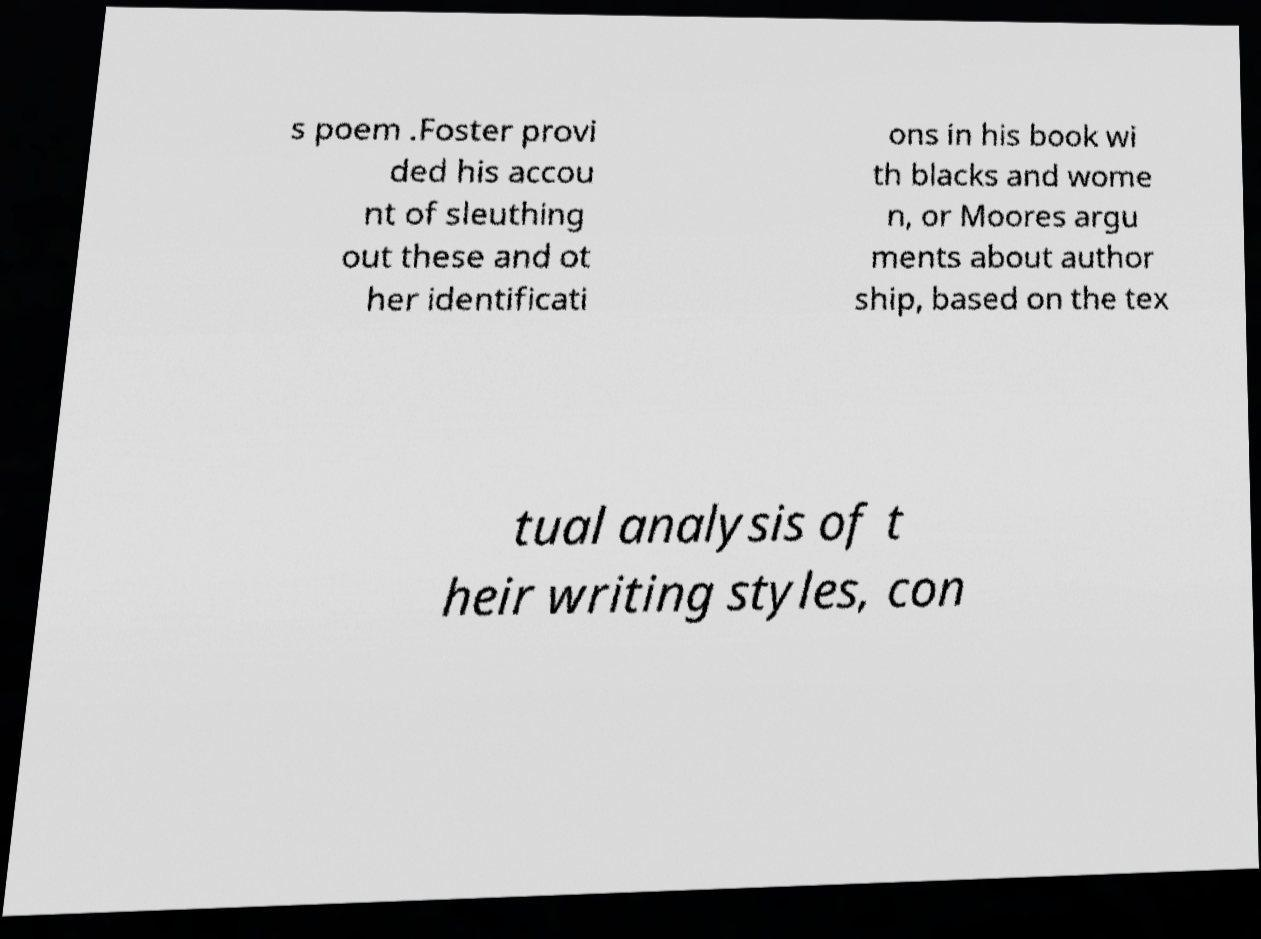Please identify and transcribe the text found in this image. s poem .Foster provi ded his accou nt of sleuthing out these and ot her identificati ons in his book wi th blacks and wome n, or Moores argu ments about author ship, based on the tex tual analysis of t heir writing styles, con 